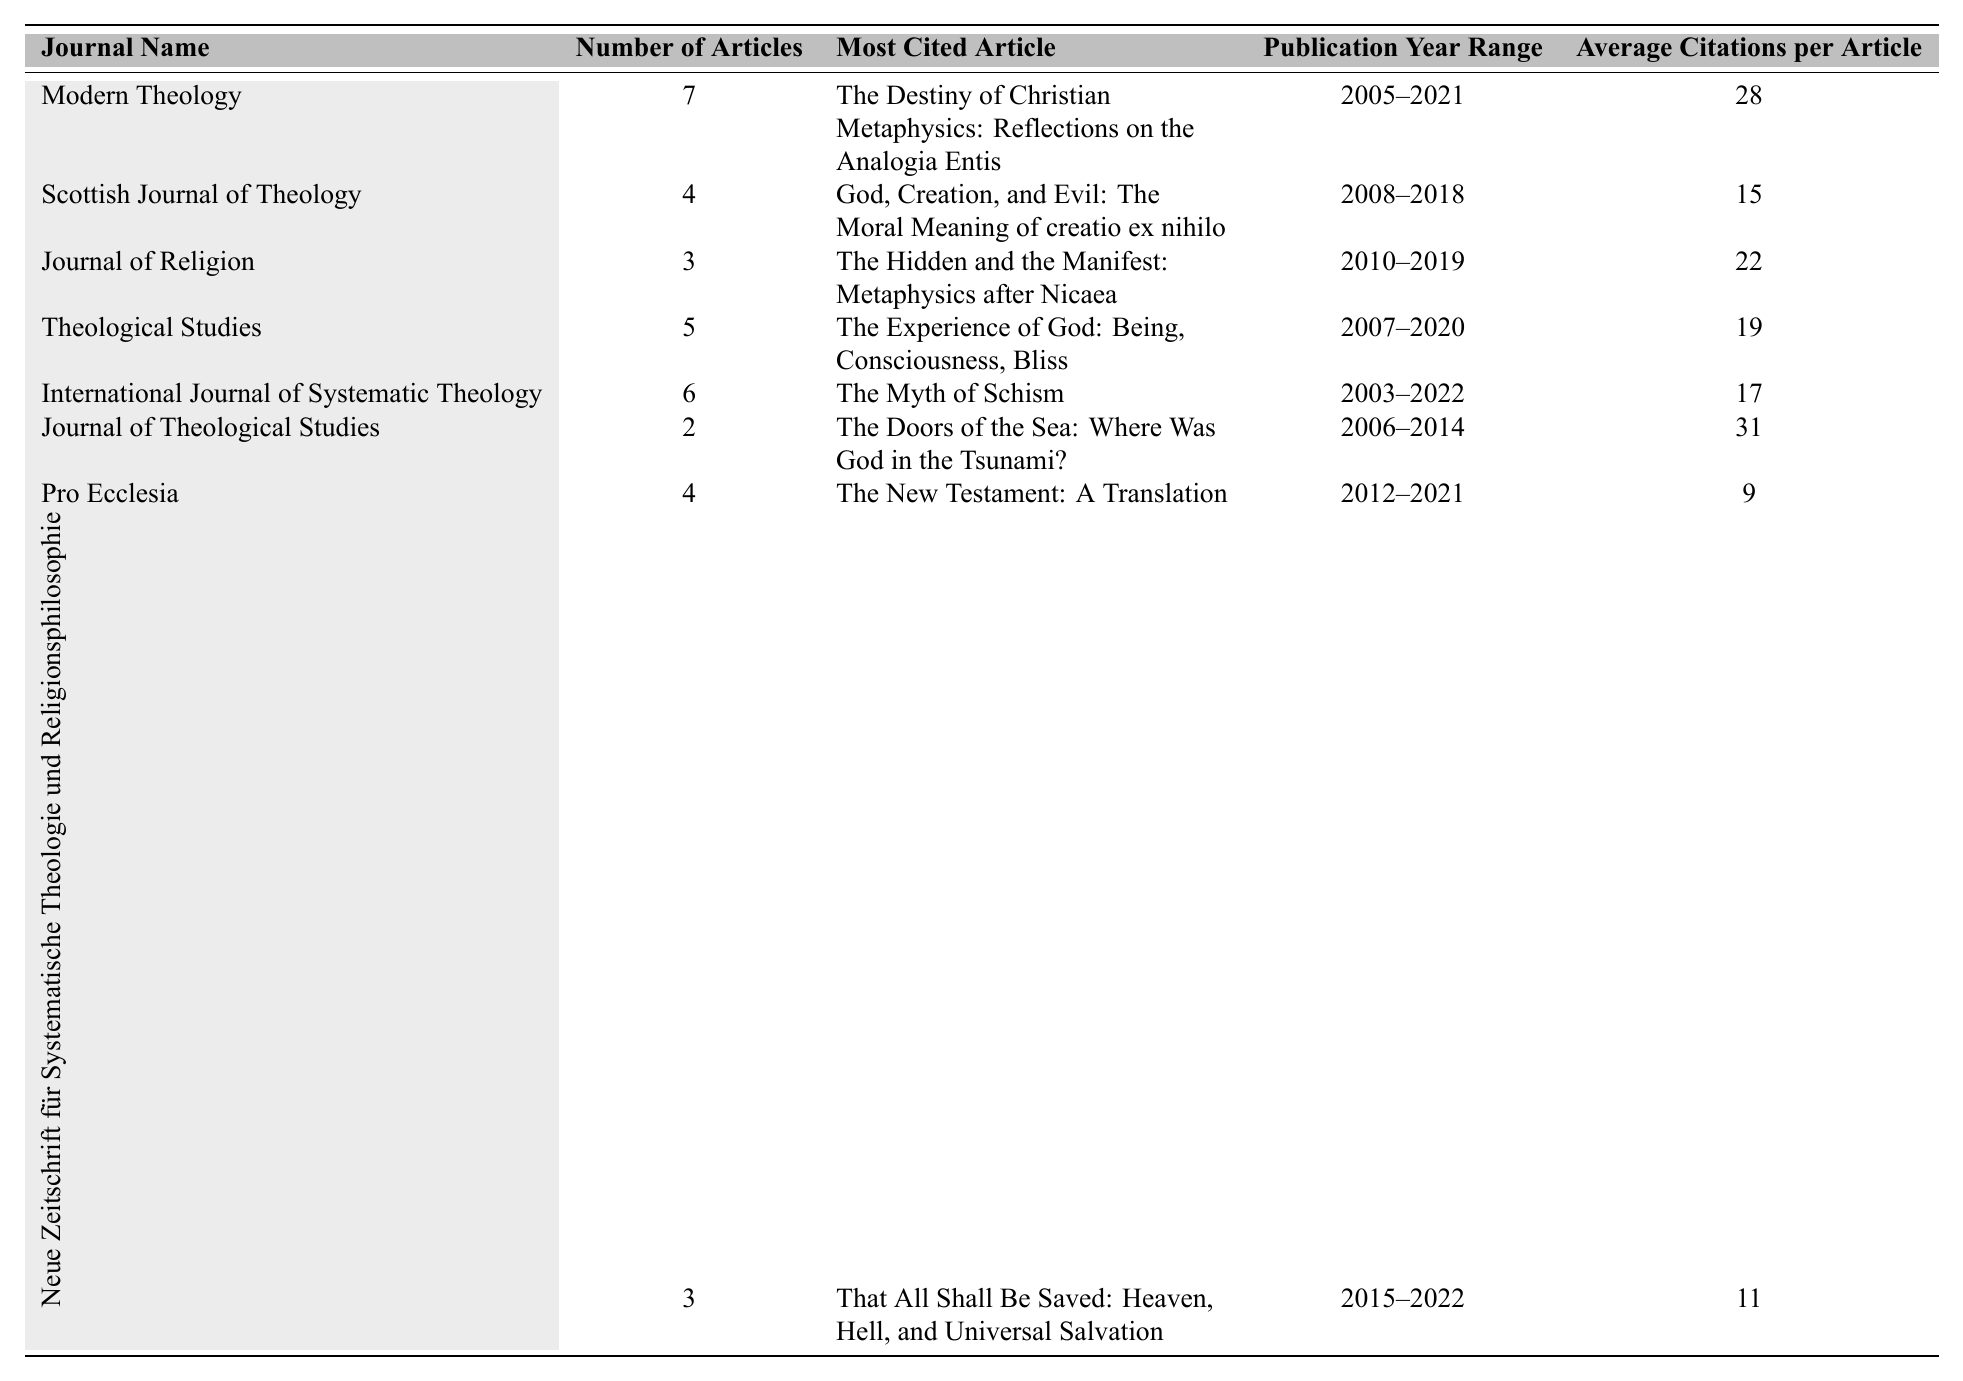What is the most cited article in the Journal of Theological Studies? According to the table, the most cited article in the Journal of Theological Studies is "The Doors of the Sea: Where Was God in the Tsunami?"
Answer: The Doors of the Sea: Where Was God in the Tsunami? How many articles were published in Modern Theology? The table shows that there were 7 articles published in Modern Theology.
Answer: 7 What is the average number of citations for articles in the Scottish Journal of Theology? In the Scottish Journal of Theology, the average number of citations per article is 15, as per the table.
Answer: 15 Which journal has the highest average citations per article? By comparing the "Average Citations per Article" column, the Journal of Theological Studies has the highest average with 31 citations.
Answer: Journal of Theological Studies What is the difference in the number of articles between Modern Theology and Pro Ecclesia? The number of articles in Modern Theology is 7 and in Pro Ecclesia is 4. The difference is 7 - 4 = 3.
Answer: 3 Which journal has the longest publication year range? The International Journal of Systematic Theology has the longest publication year range from 2003 to 2022, spanning 20 years.
Answer: International Journal of Systematic Theology Is there any journal that published exactly two articles? Yes, the Journal of Theological Studies published exactly 2 articles as indicated in the table.
Answer: Yes What is the total number of articles published across all journals listed? To find the total number of articles, we sum the articles from each journal: 7 + 4 + 3 + 5 + 6 + 2 + 4 + 3 = 34.
Answer: 34 Which journal published the most articles between 2010 and 2019? By inspecting the table, Modern Theology published articles between 2005 to 2021, Journal of Religion published from 2010 to 2019 with 3 articles, and others do not fall entirely within that range. So, none overlap specifically, but Modern Theology has the highest number in that decade.
Answer: Modern Theology What is the average number of articles across the journals listed? To find the average, sum the number of articles (34) and divide by the number of journals (8): 34/8 = 4.25.
Answer: 4.25 